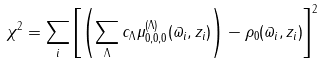Convert formula to latex. <formula><loc_0><loc_0><loc_500><loc_500>\chi ^ { 2 } = \sum _ { i } \left [ \left ( \sum _ { \Lambda } c _ { \Lambda } \mu _ { 0 , 0 , 0 } ^ { ( \Lambda ) } ( \varpi _ { i } , z _ { i } ) \right ) - \rho _ { 0 } ( \varpi _ { i } , z _ { i } ) \right ] ^ { 2 }</formula> 